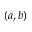<formula> <loc_0><loc_0><loc_500><loc_500>( a , b )</formula> 